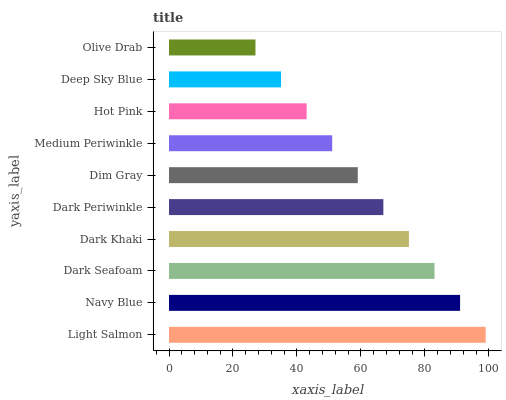Is Olive Drab the minimum?
Answer yes or no. Yes. Is Light Salmon the maximum?
Answer yes or no. Yes. Is Navy Blue the minimum?
Answer yes or no. No. Is Navy Blue the maximum?
Answer yes or no. No. Is Light Salmon greater than Navy Blue?
Answer yes or no. Yes. Is Navy Blue less than Light Salmon?
Answer yes or no. Yes. Is Navy Blue greater than Light Salmon?
Answer yes or no. No. Is Light Salmon less than Navy Blue?
Answer yes or no. No. Is Dark Periwinkle the high median?
Answer yes or no. Yes. Is Dim Gray the low median?
Answer yes or no. Yes. Is Olive Drab the high median?
Answer yes or no. No. Is Olive Drab the low median?
Answer yes or no. No. 